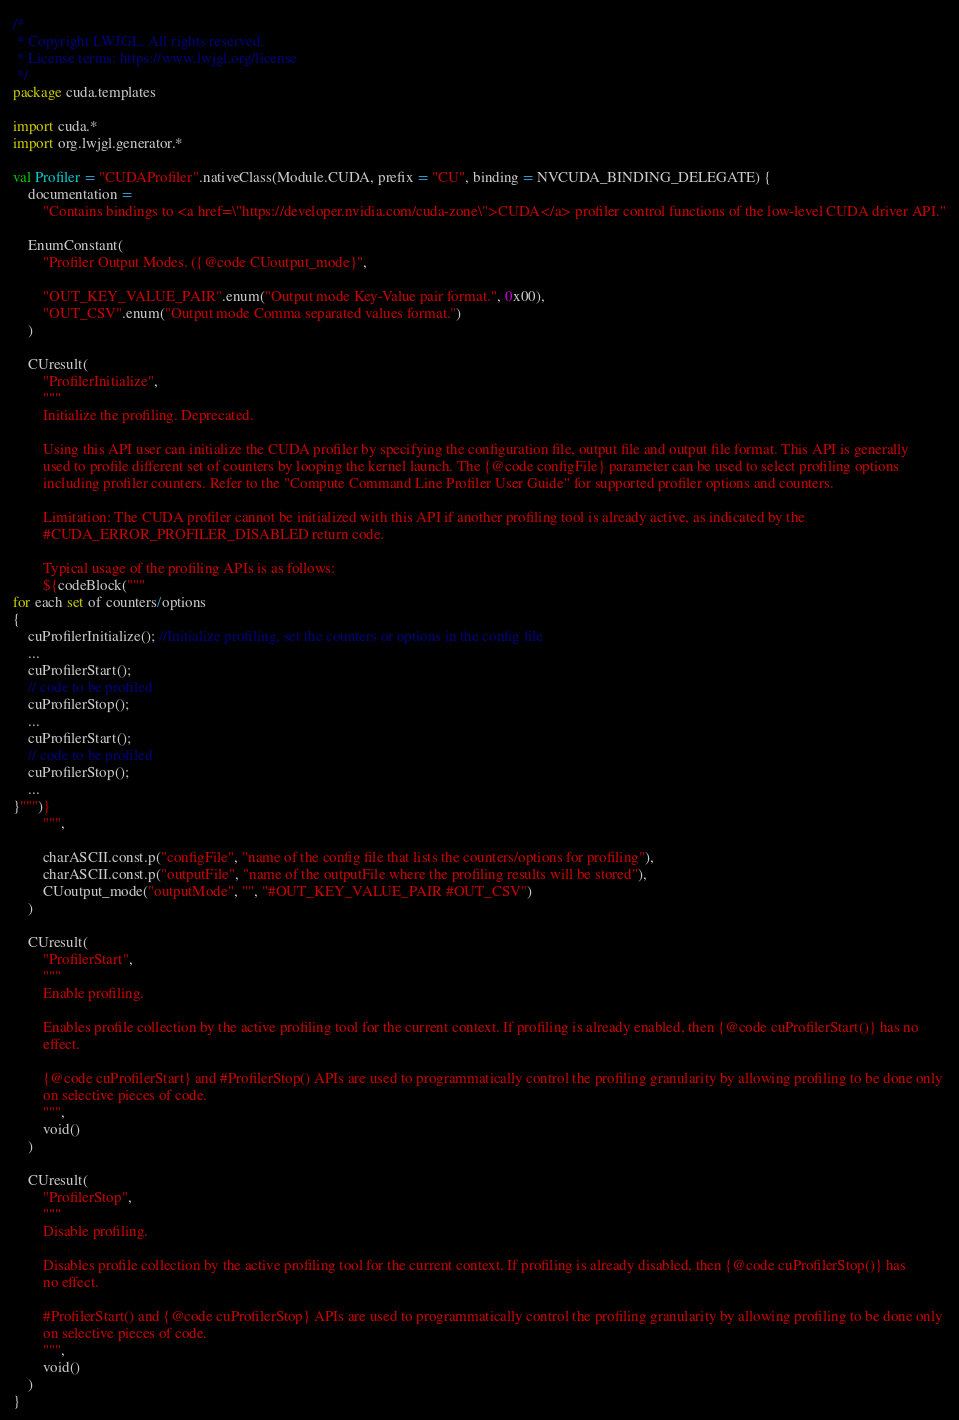<code> <loc_0><loc_0><loc_500><loc_500><_Kotlin_>/*
 * Copyright LWJGL. All rights reserved.
 * License terms: https://www.lwjgl.org/license
 */
package cuda.templates

import cuda.*
import org.lwjgl.generator.*

val Profiler = "CUDAProfiler".nativeClass(Module.CUDA, prefix = "CU", binding = NVCUDA_BINDING_DELEGATE) {
    documentation =
        "Contains bindings to <a href=\"https://developer.nvidia.com/cuda-zone\">CUDA</a> profiler control functions of the low-level CUDA driver API."

    EnumConstant(
        "Profiler Output Modes. ({@code CUoutput_mode}",

        "OUT_KEY_VALUE_PAIR".enum("Output mode Key-Value pair format.", 0x00),
        "OUT_CSV".enum("Output mode Comma separated values format.")
    )

    CUresult(
        "ProfilerInitialize",
        """
        Initialize the profiling. Deprecated.

        Using this API user can initialize the CUDA profiler by specifying the configuration file, output file and output file format. This API is generally
        used to profile different set of counters by looping the kernel launch. The {@code configFile} parameter can be used to select profiling options
        including profiler counters. Refer to the "Compute Command Line Profiler User Guide" for supported profiler options and counters.

        Limitation: The CUDA profiler cannot be initialized with this API if another profiling tool is already active, as indicated by the
        #CUDA_ERROR_PROFILER_DISABLED return code.

        Typical usage of the profiling APIs is as follows:
        ${codeBlock("""
for each set of counters/options
{
    cuProfilerInitialize(); //Initialize profiling, set the counters or options in the config file
    ...
    cuProfilerStart();
    // code to be profiled
    cuProfilerStop();
    ...
    cuProfilerStart();
    // code to be profiled
    cuProfilerStop();
    ...
}""")}
        """,

        charASCII.const.p("configFile", "name of the config file that lists the counters/options for profiling"),
        charASCII.const.p("outputFile", "name of the outputFile where the profiling results will be stored"),
        CUoutput_mode("outputMode", "", "#OUT_KEY_VALUE_PAIR #OUT_CSV")
    )

    CUresult(
        "ProfilerStart",
        """
        Enable profiling.

        Enables profile collection by the active profiling tool for the current context. If profiling is already enabled, then {@code cuProfilerStart()} has no
        effect.

        {@code cuProfilerStart} and #ProfilerStop() APIs are used to programmatically control the profiling granularity by allowing profiling to be done only
        on selective pieces of code.
        """,
        void()
    )

    CUresult(
        "ProfilerStop",
        """
        Disable profiling.

        Disables profile collection by the active profiling tool for the current context. If profiling is already disabled, then {@code cuProfilerStop()} has
        no effect.

        #ProfilerStart() and {@code cuProfilerStop} APIs are used to programmatically control the profiling granularity by allowing profiling to be done only
        on selective pieces of code.
        """,
        void()
    )
}</code> 